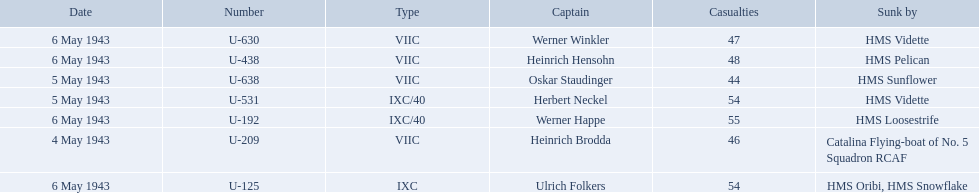What boats were lost on may 5? U-638, U-531. Who were the captains of those boats? Oskar Staudinger, Herbert Neckel. Which captain was not oskar staudinger? Herbert Neckel. 